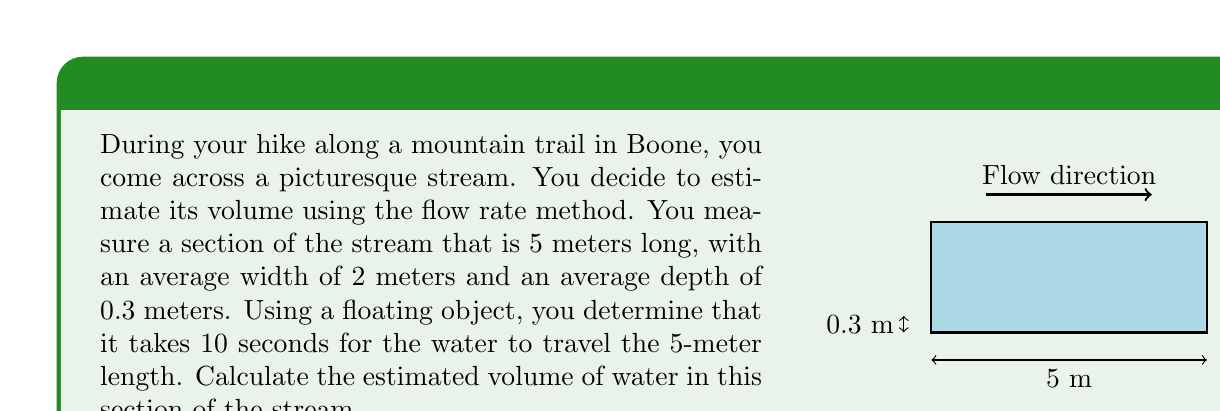Teach me how to tackle this problem. Let's approach this step-by-step:

1) First, we need to calculate the volume of the stream section:
   Volume = Length × Width × Depth
   $V = 5 \text{ m} \times 2 \text{ m} \times 0.3 \text{ m} = 3 \text{ m}^3$

2) Now, we need to calculate the flow rate. We know that the water travels 5 meters in 10 seconds. To get the flow rate in m/s:
   Flow rate = Distance / Time
   $\text{Flow rate} = \frac{5 \text{ m}}{10 \text{ s}} = 0.5 \text{ m/s}$

3) To get the volume of water flowing through the stream per second:
   Volume flow rate = Cross-sectional area × Flow rate
   Cross-sectional area = Width × Depth = $2 \text{ m} \times 0.3 \text{ m} = 0.6 \text{ m}^2$
   $\text{Volume flow rate} = 0.6 \text{ m}^2 \times 0.5 \text{ m/s} = 0.3 \text{ m}^3/\text{s}$

4) Now, to find how long it takes for the entire volume of water in the section to be replaced:
   Time = Volume / Volume flow rate
   $\text{Time} = \frac{3 \text{ m}^3}{0.3 \text{ m}^3/\text{s}} = 10 \text{ s}$

Therefore, the volume of water in this section of the stream is replaced every 10 seconds.
Answer: $3 \text{ m}^3$ 